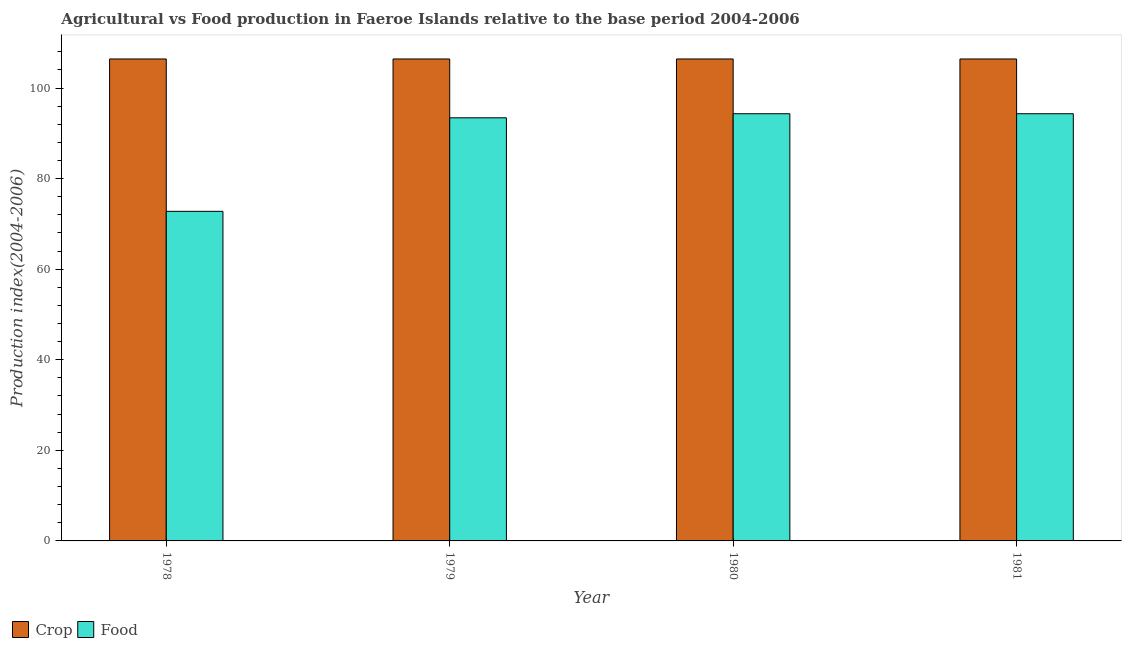How many groups of bars are there?
Your answer should be compact. 4. Are the number of bars per tick equal to the number of legend labels?
Offer a terse response. Yes. How many bars are there on the 4th tick from the right?
Make the answer very short. 2. What is the label of the 2nd group of bars from the left?
Your answer should be compact. 1979. In how many cases, is the number of bars for a given year not equal to the number of legend labels?
Offer a very short reply. 0. What is the crop production index in 1978?
Offer a very short reply. 106.41. Across all years, what is the maximum food production index?
Ensure brevity in your answer.  94.32. Across all years, what is the minimum crop production index?
Give a very brief answer. 106.41. In which year was the crop production index maximum?
Keep it short and to the point. 1978. In which year was the crop production index minimum?
Keep it short and to the point. 1978. What is the total food production index in the graph?
Offer a terse response. 354.83. What is the difference between the crop production index in 1978 and that in 1980?
Your answer should be very brief. 0. What is the difference between the crop production index in 1978 and the food production index in 1979?
Provide a short and direct response. 0. What is the average food production index per year?
Ensure brevity in your answer.  88.71. In the year 1981, what is the difference between the food production index and crop production index?
Keep it short and to the point. 0. In how many years, is the crop production index greater than the average crop production index taken over all years?
Give a very brief answer. 0. What does the 2nd bar from the left in 1981 represents?
Offer a terse response. Food. What does the 1st bar from the right in 1978 represents?
Your response must be concise. Food. How many bars are there?
Provide a short and direct response. 8. Are all the bars in the graph horizontal?
Your response must be concise. No. Are the values on the major ticks of Y-axis written in scientific E-notation?
Offer a very short reply. No. Does the graph contain any zero values?
Make the answer very short. No. Where does the legend appear in the graph?
Offer a terse response. Bottom left. How are the legend labels stacked?
Offer a very short reply. Horizontal. What is the title of the graph?
Keep it short and to the point. Agricultural vs Food production in Faeroe Islands relative to the base period 2004-2006. What is the label or title of the Y-axis?
Give a very brief answer. Production index(2004-2006). What is the Production index(2004-2006) in Crop in 1978?
Make the answer very short. 106.41. What is the Production index(2004-2006) of Food in 1978?
Ensure brevity in your answer.  72.77. What is the Production index(2004-2006) in Crop in 1979?
Give a very brief answer. 106.41. What is the Production index(2004-2006) in Food in 1979?
Your answer should be compact. 93.42. What is the Production index(2004-2006) of Crop in 1980?
Give a very brief answer. 106.41. What is the Production index(2004-2006) in Food in 1980?
Offer a very short reply. 94.32. What is the Production index(2004-2006) in Crop in 1981?
Your answer should be very brief. 106.41. What is the Production index(2004-2006) of Food in 1981?
Your answer should be very brief. 94.32. Across all years, what is the maximum Production index(2004-2006) of Crop?
Provide a short and direct response. 106.41. Across all years, what is the maximum Production index(2004-2006) of Food?
Your answer should be compact. 94.32. Across all years, what is the minimum Production index(2004-2006) of Crop?
Your answer should be compact. 106.41. Across all years, what is the minimum Production index(2004-2006) of Food?
Offer a very short reply. 72.77. What is the total Production index(2004-2006) of Crop in the graph?
Your response must be concise. 425.64. What is the total Production index(2004-2006) in Food in the graph?
Offer a terse response. 354.83. What is the difference between the Production index(2004-2006) of Food in 1978 and that in 1979?
Keep it short and to the point. -20.65. What is the difference between the Production index(2004-2006) of Food in 1978 and that in 1980?
Provide a succinct answer. -21.55. What is the difference between the Production index(2004-2006) of Food in 1978 and that in 1981?
Provide a succinct answer. -21.55. What is the difference between the Production index(2004-2006) in Crop in 1979 and that in 1980?
Your answer should be compact. 0. What is the difference between the Production index(2004-2006) in Crop in 1979 and that in 1981?
Offer a terse response. 0. What is the difference between the Production index(2004-2006) of Food in 1979 and that in 1981?
Your answer should be very brief. -0.9. What is the difference between the Production index(2004-2006) of Crop in 1980 and that in 1981?
Your answer should be compact. 0. What is the difference between the Production index(2004-2006) in Food in 1980 and that in 1981?
Provide a succinct answer. 0. What is the difference between the Production index(2004-2006) in Crop in 1978 and the Production index(2004-2006) in Food in 1979?
Provide a short and direct response. 12.99. What is the difference between the Production index(2004-2006) in Crop in 1978 and the Production index(2004-2006) in Food in 1980?
Provide a short and direct response. 12.09. What is the difference between the Production index(2004-2006) of Crop in 1978 and the Production index(2004-2006) of Food in 1981?
Make the answer very short. 12.09. What is the difference between the Production index(2004-2006) in Crop in 1979 and the Production index(2004-2006) in Food in 1980?
Offer a very short reply. 12.09. What is the difference between the Production index(2004-2006) of Crop in 1979 and the Production index(2004-2006) of Food in 1981?
Make the answer very short. 12.09. What is the difference between the Production index(2004-2006) of Crop in 1980 and the Production index(2004-2006) of Food in 1981?
Your answer should be very brief. 12.09. What is the average Production index(2004-2006) of Crop per year?
Keep it short and to the point. 106.41. What is the average Production index(2004-2006) of Food per year?
Provide a succinct answer. 88.71. In the year 1978, what is the difference between the Production index(2004-2006) in Crop and Production index(2004-2006) in Food?
Your answer should be compact. 33.64. In the year 1979, what is the difference between the Production index(2004-2006) of Crop and Production index(2004-2006) of Food?
Give a very brief answer. 12.99. In the year 1980, what is the difference between the Production index(2004-2006) of Crop and Production index(2004-2006) of Food?
Ensure brevity in your answer.  12.09. In the year 1981, what is the difference between the Production index(2004-2006) in Crop and Production index(2004-2006) in Food?
Make the answer very short. 12.09. What is the ratio of the Production index(2004-2006) in Crop in 1978 to that in 1979?
Provide a short and direct response. 1. What is the ratio of the Production index(2004-2006) in Food in 1978 to that in 1979?
Offer a terse response. 0.78. What is the ratio of the Production index(2004-2006) in Crop in 1978 to that in 1980?
Provide a short and direct response. 1. What is the ratio of the Production index(2004-2006) of Food in 1978 to that in 1980?
Your answer should be very brief. 0.77. What is the ratio of the Production index(2004-2006) in Food in 1978 to that in 1981?
Your answer should be compact. 0.77. What is the ratio of the Production index(2004-2006) of Crop in 1979 to that in 1980?
Your response must be concise. 1. What is the ratio of the Production index(2004-2006) of Food in 1979 to that in 1980?
Provide a short and direct response. 0.99. What is the ratio of the Production index(2004-2006) of Crop in 1979 to that in 1981?
Your answer should be compact. 1. What is the ratio of the Production index(2004-2006) of Food in 1979 to that in 1981?
Your answer should be compact. 0.99. What is the ratio of the Production index(2004-2006) in Crop in 1980 to that in 1981?
Offer a terse response. 1. What is the ratio of the Production index(2004-2006) in Food in 1980 to that in 1981?
Provide a short and direct response. 1. What is the difference between the highest and the lowest Production index(2004-2006) in Crop?
Provide a succinct answer. 0. What is the difference between the highest and the lowest Production index(2004-2006) in Food?
Provide a short and direct response. 21.55. 